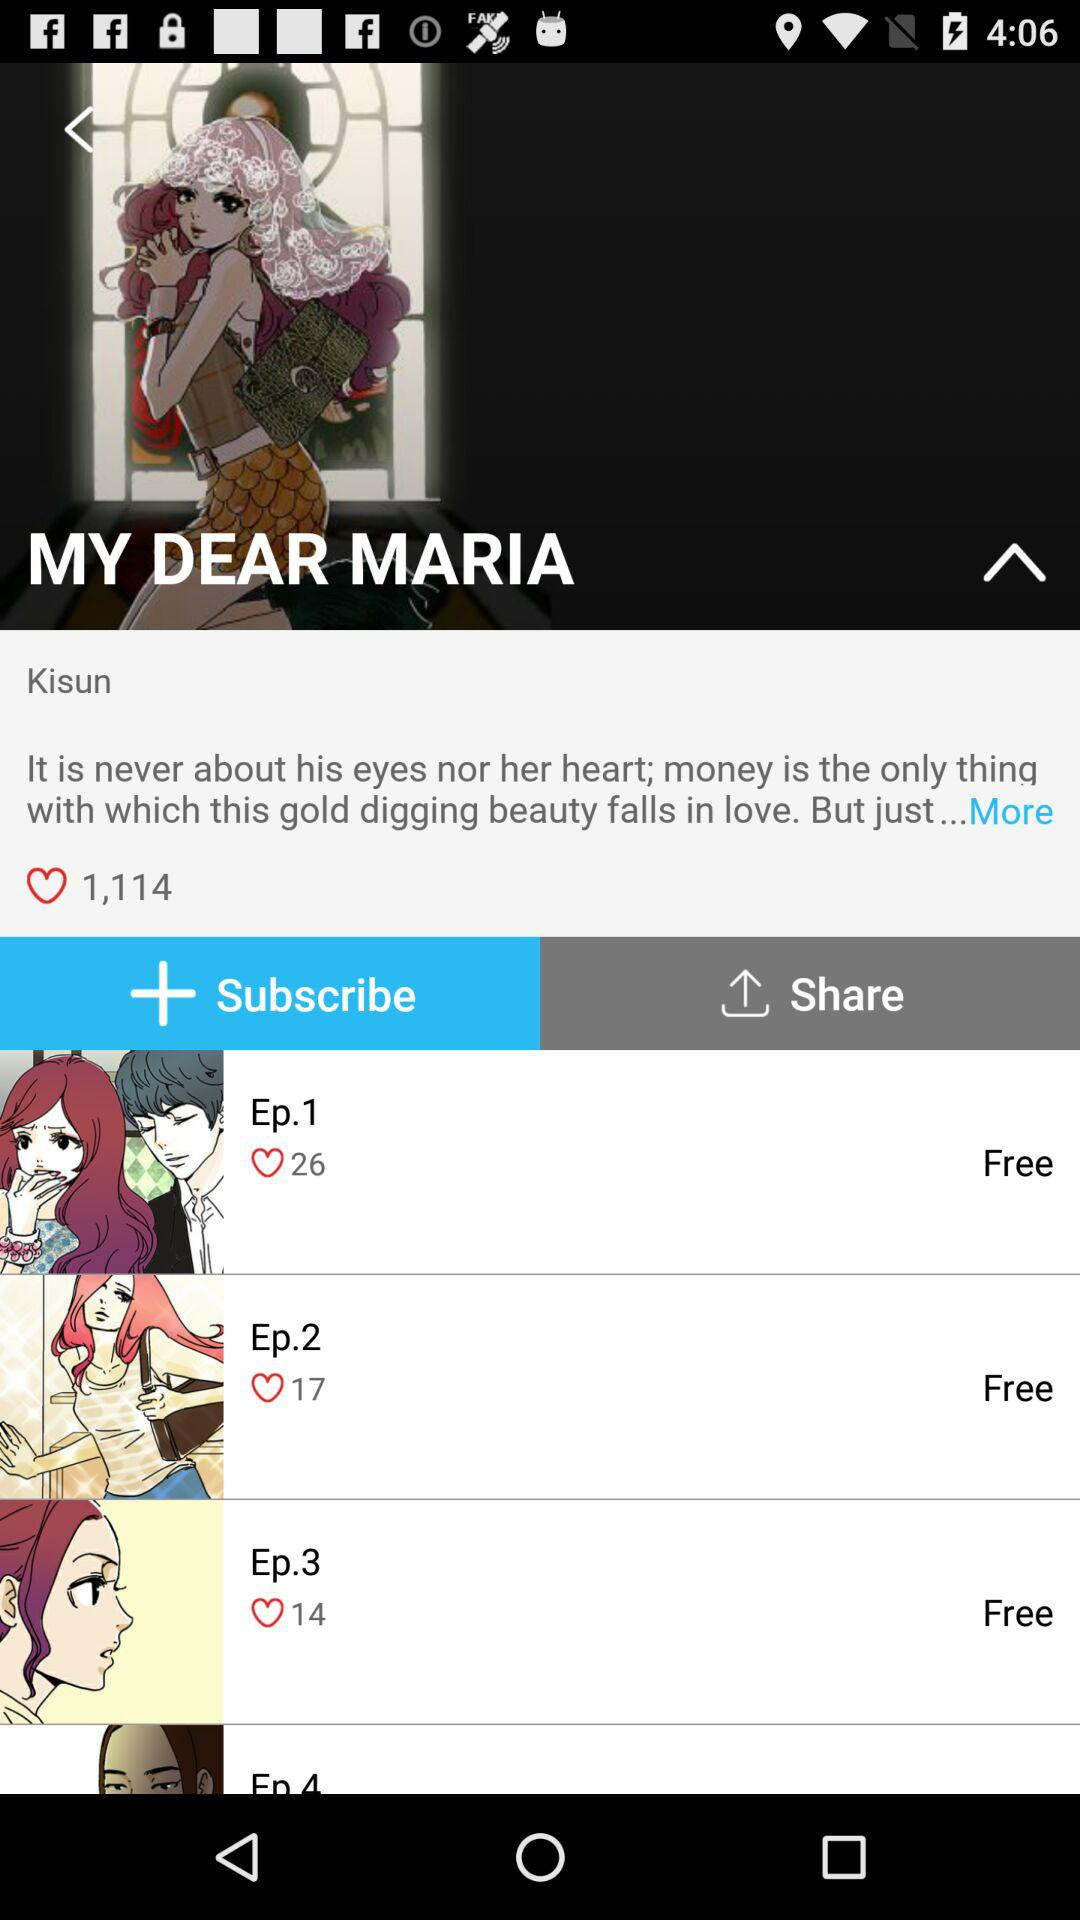How many episodes are there in Season 11?
When the provided information is insufficient, respond with <no answer>. <no answer> 